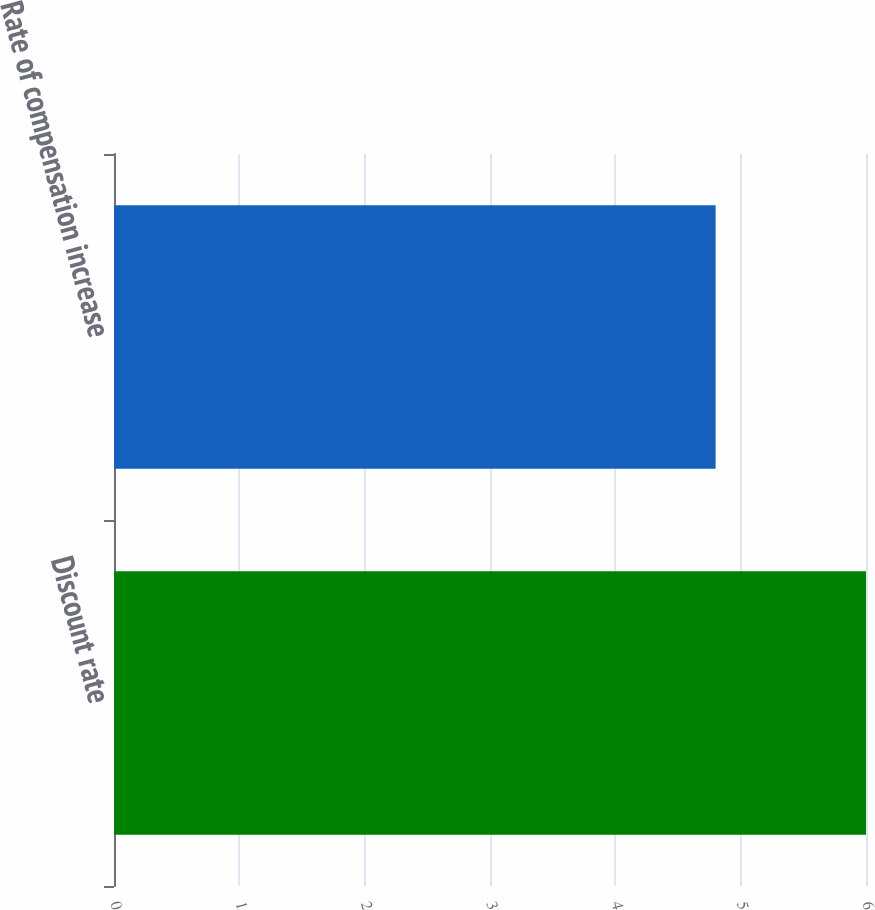<chart> <loc_0><loc_0><loc_500><loc_500><bar_chart><fcel>Discount rate<fcel>Rate of compensation increase<nl><fcel>6<fcel>4.8<nl></chart> 